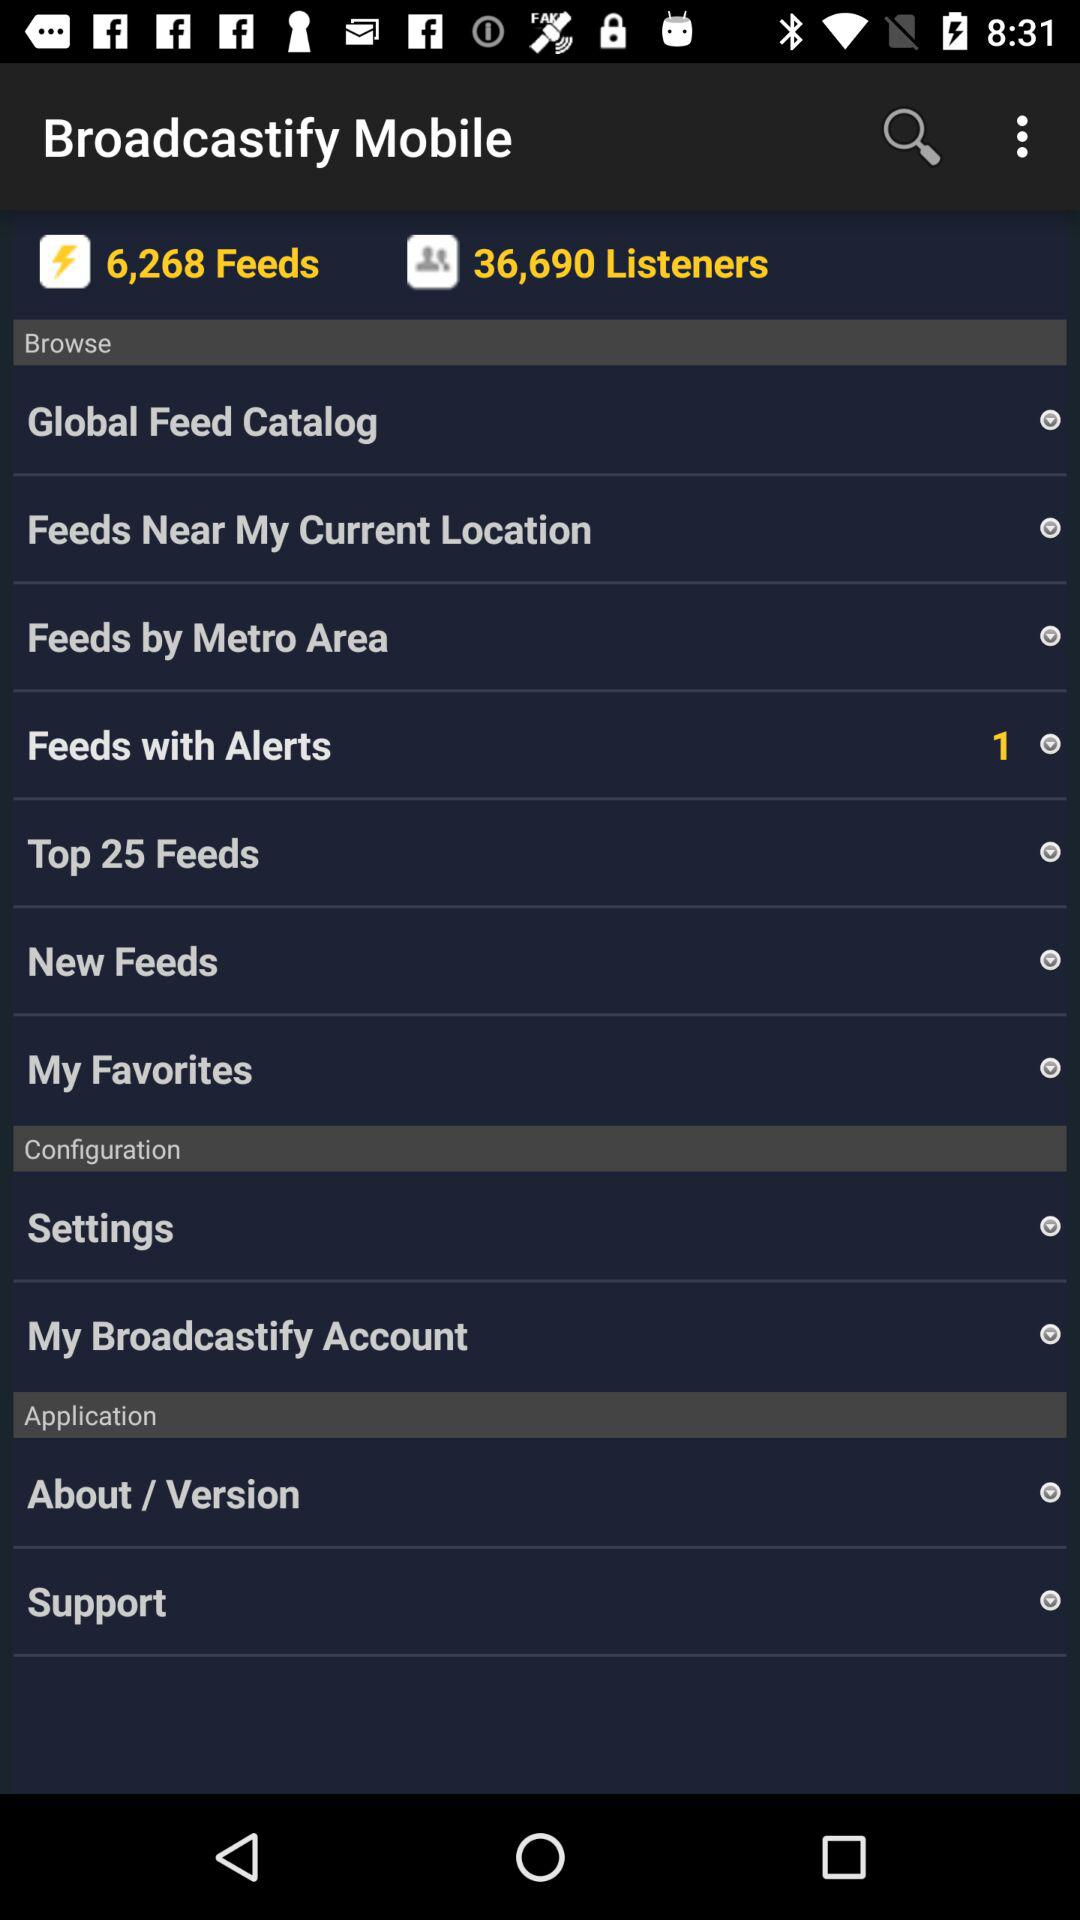How many listeners are there? There are 36,690 listeners. 